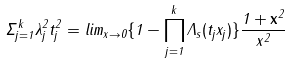<formula> <loc_0><loc_0><loc_500><loc_500>\Sigma _ { j = 1 } ^ { k } \lambda ^ { 2 } _ { j } t _ { j } ^ { 2 } = l i m _ { \| x \| \rightarrow 0 } \{ 1 - \prod _ { j = 1 } ^ { k } \Lambda _ { s } ( t _ { j } x _ { j } ) \} \frac { 1 + \| \mathbf x \| ^ { 2 } } { \| x \| ^ { 2 } }</formula> 